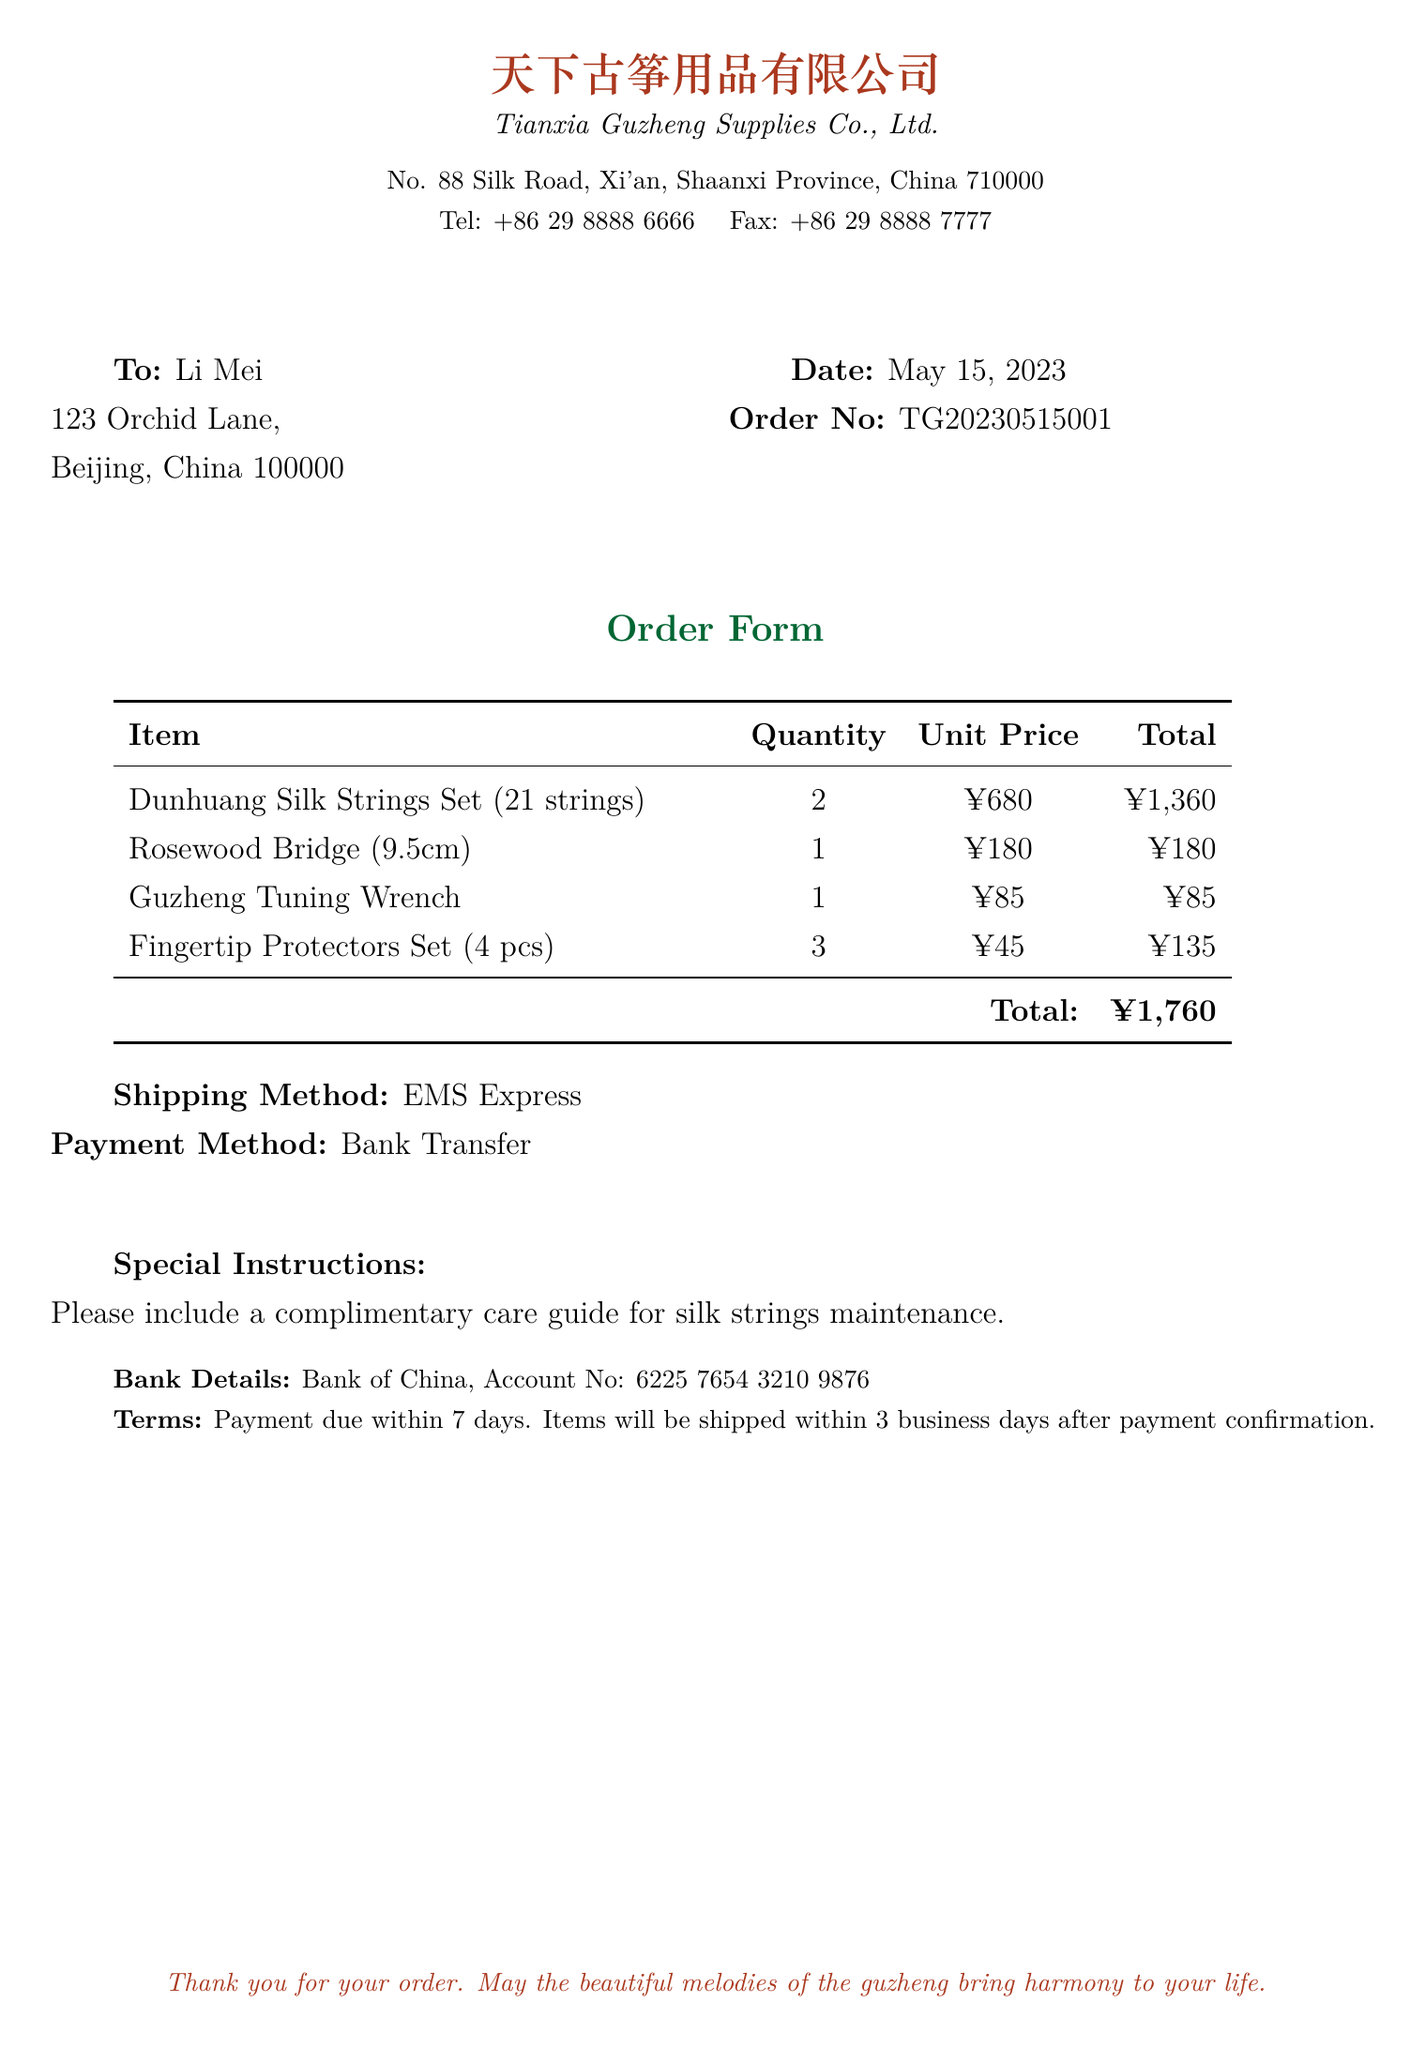what is the name of the supplier? The name of the supplier is mentioned at the top of the document as "天下古筝用品有限公司" or "Tianxia Guzheng Supplies Co., Ltd."
Answer: Tianxia Guzheng Supplies Co., Ltd what is the order number? The order number is indicated in the document as "TG20230515001."
Answer: TG20230515001 how many Dunhuang Silk Strings Sets were ordered? The quantity of Dunhuang Silk Strings Sets ordered is specified in the table as "2."
Answer: 2 what is the total amount of the order? The total amount is given at the bottom of the table as "¥1,760."
Answer: ¥1,760 what payment method is used for this order? The payment method is stated in the document as "Bank Transfer."
Answer: Bank Transfer what special instruction was included with the order? The special instruction requests a "complimentary care guide for silk strings maintenance."
Answer: complimentary care guide for silk strings maintenance which shipping method is specified? The shipping method is declared as "EMS Express."
Answer: EMS Express when was the order dated? The date of the order is recorded as "May 15, 2023."
Answer: May 15, 2023 how many pieces are in the Fingertip Protectors Set? The quantity of items in the Fingertip Protectors Set is mentioned as "4 pcs."
Answer: 4 pcs 